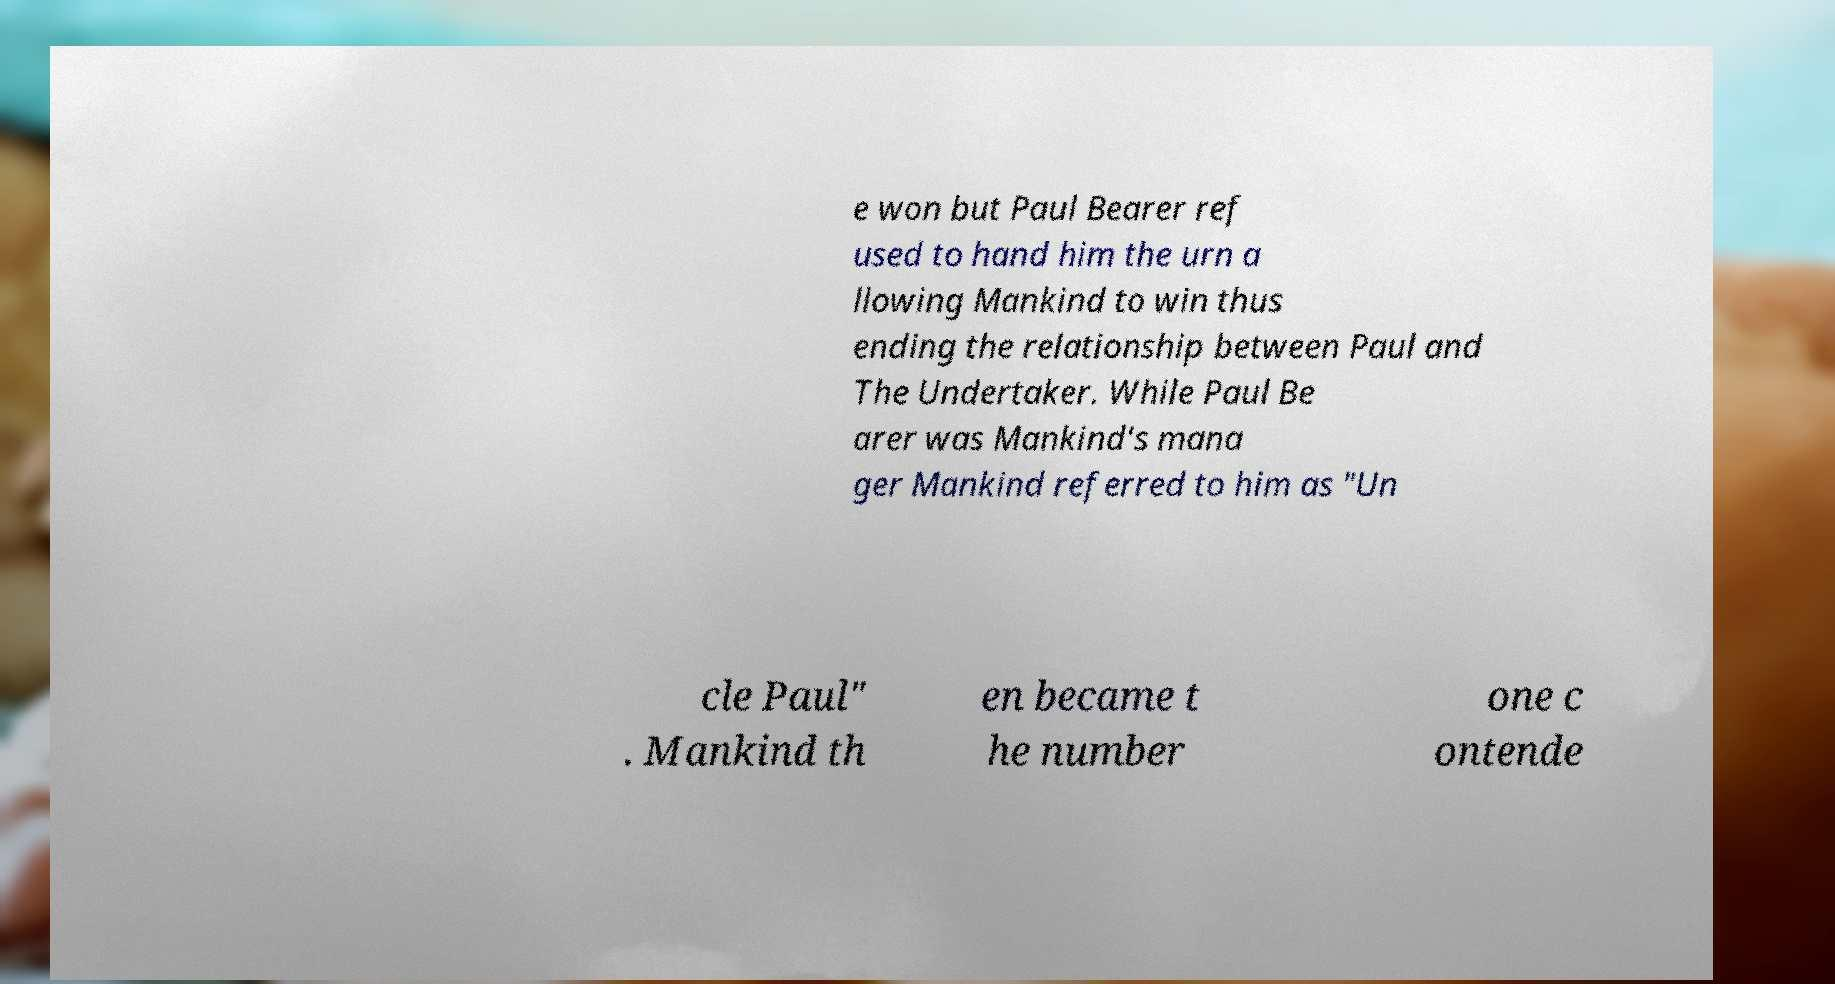For documentation purposes, I need the text within this image transcribed. Could you provide that? e won but Paul Bearer ref used to hand him the urn a llowing Mankind to win thus ending the relationship between Paul and The Undertaker. While Paul Be arer was Mankind's mana ger Mankind referred to him as "Un cle Paul" . Mankind th en became t he number one c ontende 